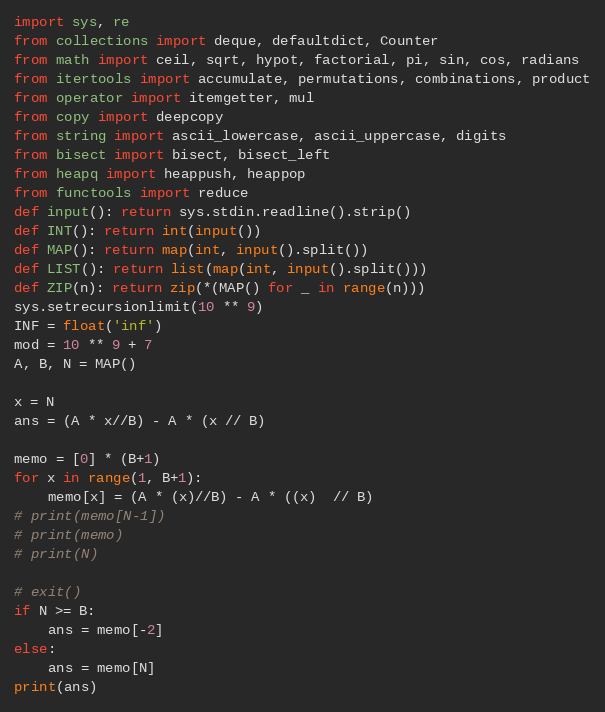<code> <loc_0><loc_0><loc_500><loc_500><_Python_>import sys, re
from collections import deque, defaultdict, Counter
from math import ceil, sqrt, hypot, factorial, pi, sin, cos, radians
from itertools import accumulate, permutations, combinations, product
from operator import itemgetter, mul
from copy import deepcopy
from string import ascii_lowercase, ascii_uppercase, digits
from bisect import bisect, bisect_left
from heapq import heappush, heappop
from functools import reduce
def input(): return sys.stdin.readline().strip()
def INT(): return int(input())
def MAP(): return map(int, input().split())
def LIST(): return list(map(int, input().split()))
def ZIP(n): return zip(*(MAP() for _ in range(n)))
sys.setrecursionlimit(10 ** 9)
INF = float('inf')
mod = 10 ** 9 + 7
A, B, N = MAP()

x = N
ans = (A * x//B) - A * (x // B)

memo = [0] * (B+1)
for x in range(1, B+1):
    memo[x] = (A * (x)//B) - A * ((x)  // B)
# print(memo[N-1])
# print(memo)
# print(N)

# exit()
if N >= B:
    ans = memo[-2]
else:
    ans = memo[N]
print(ans)
</code> 